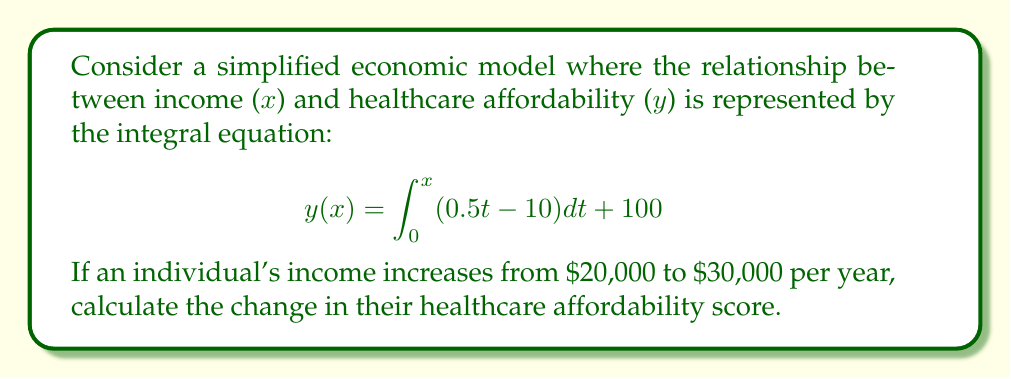Solve this math problem. 1) To solve this problem, we need to evaluate the integral equation for both income levels and find the difference.

2) Let's start with $x_1 = 20$ (representing $20,000) and $x_2 = 30$ (representing $30,000).

3) For $x_1 = 20$:
   $$y(20) = \int_0^{20} (0.5t - 10) dt + 100$$
   $$= [0.25t^2 - 10t]_0^{20} + 100$$
   $$= (0.25 \cdot 400 - 200) - (0 - 0) + 100$$
   $$= 100 - 200 + 100 = 0$$

4) For $x_2 = 30$:
   $$y(30) = \int_0^{30} (0.5t - 10) dt + 100$$
   $$= [0.25t^2 - 10t]_0^{30} + 100$$
   $$= (0.25 \cdot 900 - 300) - (0 - 0) + 100$$
   $$= 225 - 300 + 100 = 25$$

5) The change in healthcare affordability is the difference between these two values:
   $$\Delta y = y(30) - y(20) = 25 - 0 = 25$$
Answer: 25 